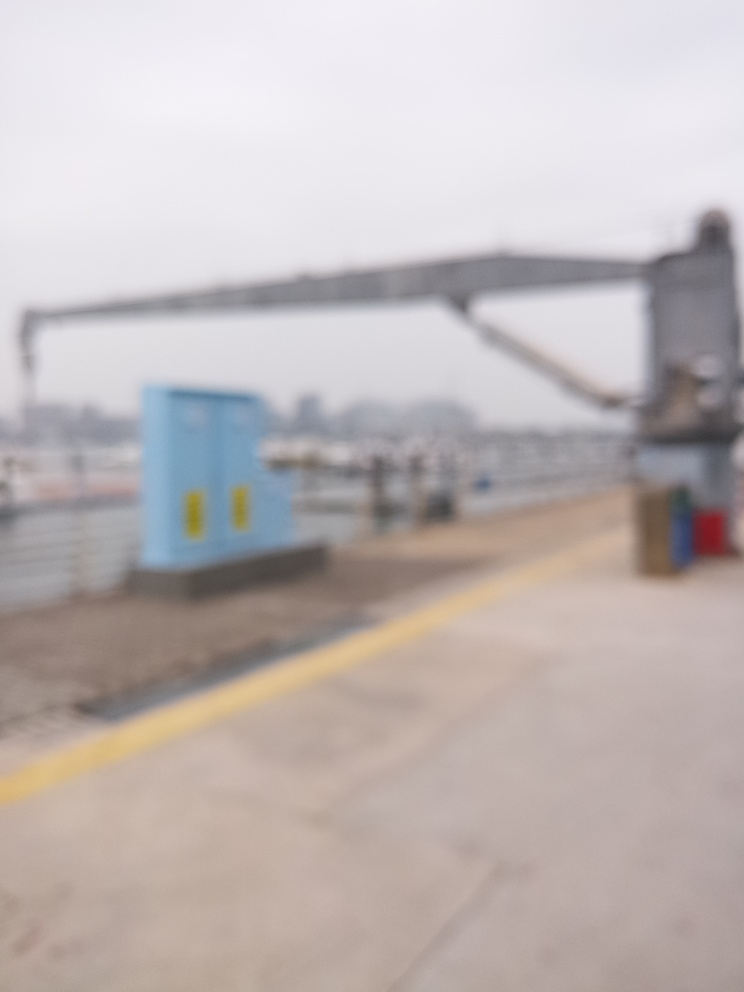Despite the blur, what kind of mood or atmosphere does this image evoke? The obscured details and the hazy view give off a sense of stillness and quiet, potentially evoking feelings of solitude or introspection. 